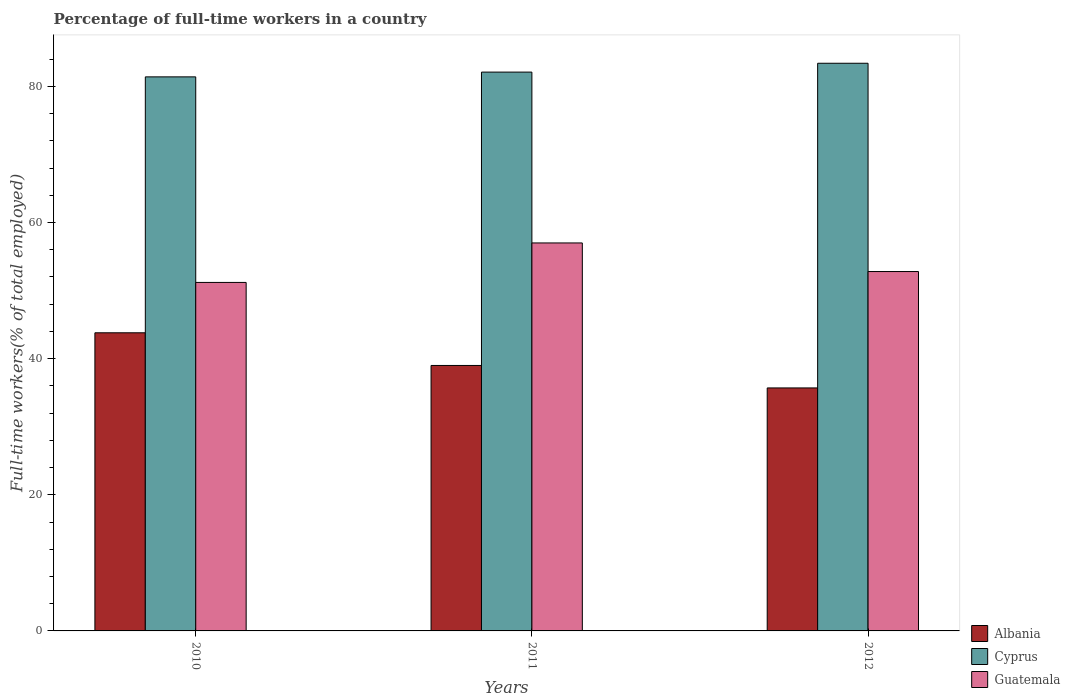How many different coloured bars are there?
Provide a short and direct response. 3. How many groups of bars are there?
Your answer should be compact. 3. Are the number of bars per tick equal to the number of legend labels?
Make the answer very short. Yes. Are the number of bars on each tick of the X-axis equal?
Give a very brief answer. Yes. How many bars are there on the 1st tick from the right?
Keep it short and to the point. 3. In how many cases, is the number of bars for a given year not equal to the number of legend labels?
Provide a succinct answer. 0. What is the percentage of full-time workers in Albania in 2010?
Your answer should be compact. 43.8. Across all years, what is the maximum percentage of full-time workers in Albania?
Provide a succinct answer. 43.8. Across all years, what is the minimum percentage of full-time workers in Guatemala?
Your answer should be compact. 51.2. In which year was the percentage of full-time workers in Albania maximum?
Provide a short and direct response. 2010. What is the total percentage of full-time workers in Albania in the graph?
Provide a short and direct response. 118.5. What is the difference between the percentage of full-time workers in Albania in 2011 and that in 2012?
Your answer should be very brief. 3.3. What is the difference between the percentage of full-time workers in Cyprus in 2010 and the percentage of full-time workers in Albania in 2012?
Keep it short and to the point. 45.7. What is the average percentage of full-time workers in Albania per year?
Provide a short and direct response. 39.5. In the year 2012, what is the difference between the percentage of full-time workers in Guatemala and percentage of full-time workers in Albania?
Provide a succinct answer. 17.1. In how many years, is the percentage of full-time workers in Guatemala greater than 40 %?
Make the answer very short. 3. What is the ratio of the percentage of full-time workers in Cyprus in 2010 to that in 2011?
Provide a short and direct response. 0.99. Is the percentage of full-time workers in Cyprus in 2010 less than that in 2012?
Your response must be concise. Yes. Is the difference between the percentage of full-time workers in Guatemala in 2010 and 2012 greater than the difference between the percentage of full-time workers in Albania in 2010 and 2012?
Offer a terse response. No. What is the difference between the highest and the second highest percentage of full-time workers in Guatemala?
Ensure brevity in your answer.  4.2. In how many years, is the percentage of full-time workers in Albania greater than the average percentage of full-time workers in Albania taken over all years?
Provide a short and direct response. 1. Is the sum of the percentage of full-time workers in Cyprus in 2010 and 2011 greater than the maximum percentage of full-time workers in Guatemala across all years?
Your answer should be very brief. Yes. What does the 2nd bar from the left in 2012 represents?
Offer a terse response. Cyprus. What does the 2nd bar from the right in 2011 represents?
Provide a short and direct response. Cyprus. How many years are there in the graph?
Provide a succinct answer. 3. Does the graph contain any zero values?
Keep it short and to the point. No. Does the graph contain grids?
Your answer should be very brief. No. How are the legend labels stacked?
Ensure brevity in your answer.  Vertical. What is the title of the graph?
Keep it short and to the point. Percentage of full-time workers in a country. Does "Belarus" appear as one of the legend labels in the graph?
Ensure brevity in your answer.  No. What is the label or title of the X-axis?
Keep it short and to the point. Years. What is the label or title of the Y-axis?
Provide a short and direct response. Full-time workers(% of total employed). What is the Full-time workers(% of total employed) of Albania in 2010?
Offer a terse response. 43.8. What is the Full-time workers(% of total employed) in Cyprus in 2010?
Provide a succinct answer. 81.4. What is the Full-time workers(% of total employed) in Guatemala in 2010?
Offer a very short reply. 51.2. What is the Full-time workers(% of total employed) of Cyprus in 2011?
Your answer should be compact. 82.1. What is the Full-time workers(% of total employed) of Guatemala in 2011?
Your answer should be very brief. 57. What is the Full-time workers(% of total employed) of Albania in 2012?
Give a very brief answer. 35.7. What is the Full-time workers(% of total employed) of Cyprus in 2012?
Ensure brevity in your answer.  83.4. What is the Full-time workers(% of total employed) in Guatemala in 2012?
Keep it short and to the point. 52.8. Across all years, what is the maximum Full-time workers(% of total employed) in Albania?
Your answer should be very brief. 43.8. Across all years, what is the maximum Full-time workers(% of total employed) in Cyprus?
Provide a short and direct response. 83.4. Across all years, what is the minimum Full-time workers(% of total employed) of Albania?
Keep it short and to the point. 35.7. Across all years, what is the minimum Full-time workers(% of total employed) in Cyprus?
Ensure brevity in your answer.  81.4. Across all years, what is the minimum Full-time workers(% of total employed) of Guatemala?
Provide a succinct answer. 51.2. What is the total Full-time workers(% of total employed) in Albania in the graph?
Offer a terse response. 118.5. What is the total Full-time workers(% of total employed) in Cyprus in the graph?
Provide a short and direct response. 246.9. What is the total Full-time workers(% of total employed) in Guatemala in the graph?
Provide a short and direct response. 161. What is the difference between the Full-time workers(% of total employed) in Guatemala in 2010 and that in 2011?
Offer a terse response. -5.8. What is the difference between the Full-time workers(% of total employed) of Cyprus in 2010 and that in 2012?
Your answer should be very brief. -2. What is the difference between the Full-time workers(% of total employed) in Albania in 2011 and that in 2012?
Ensure brevity in your answer.  3.3. What is the difference between the Full-time workers(% of total employed) in Cyprus in 2011 and that in 2012?
Provide a succinct answer. -1.3. What is the difference between the Full-time workers(% of total employed) in Guatemala in 2011 and that in 2012?
Keep it short and to the point. 4.2. What is the difference between the Full-time workers(% of total employed) in Albania in 2010 and the Full-time workers(% of total employed) in Cyprus in 2011?
Provide a short and direct response. -38.3. What is the difference between the Full-time workers(% of total employed) of Cyprus in 2010 and the Full-time workers(% of total employed) of Guatemala in 2011?
Keep it short and to the point. 24.4. What is the difference between the Full-time workers(% of total employed) in Albania in 2010 and the Full-time workers(% of total employed) in Cyprus in 2012?
Your answer should be compact. -39.6. What is the difference between the Full-time workers(% of total employed) in Cyprus in 2010 and the Full-time workers(% of total employed) in Guatemala in 2012?
Your answer should be very brief. 28.6. What is the difference between the Full-time workers(% of total employed) of Albania in 2011 and the Full-time workers(% of total employed) of Cyprus in 2012?
Your answer should be very brief. -44.4. What is the difference between the Full-time workers(% of total employed) of Cyprus in 2011 and the Full-time workers(% of total employed) of Guatemala in 2012?
Provide a succinct answer. 29.3. What is the average Full-time workers(% of total employed) of Albania per year?
Your answer should be very brief. 39.5. What is the average Full-time workers(% of total employed) in Cyprus per year?
Make the answer very short. 82.3. What is the average Full-time workers(% of total employed) in Guatemala per year?
Make the answer very short. 53.67. In the year 2010, what is the difference between the Full-time workers(% of total employed) in Albania and Full-time workers(% of total employed) in Cyprus?
Your answer should be compact. -37.6. In the year 2010, what is the difference between the Full-time workers(% of total employed) in Albania and Full-time workers(% of total employed) in Guatemala?
Provide a succinct answer. -7.4. In the year 2010, what is the difference between the Full-time workers(% of total employed) in Cyprus and Full-time workers(% of total employed) in Guatemala?
Give a very brief answer. 30.2. In the year 2011, what is the difference between the Full-time workers(% of total employed) of Albania and Full-time workers(% of total employed) of Cyprus?
Your answer should be very brief. -43.1. In the year 2011, what is the difference between the Full-time workers(% of total employed) of Albania and Full-time workers(% of total employed) of Guatemala?
Your answer should be very brief. -18. In the year 2011, what is the difference between the Full-time workers(% of total employed) in Cyprus and Full-time workers(% of total employed) in Guatemala?
Give a very brief answer. 25.1. In the year 2012, what is the difference between the Full-time workers(% of total employed) of Albania and Full-time workers(% of total employed) of Cyprus?
Offer a very short reply. -47.7. In the year 2012, what is the difference between the Full-time workers(% of total employed) in Albania and Full-time workers(% of total employed) in Guatemala?
Your answer should be compact. -17.1. In the year 2012, what is the difference between the Full-time workers(% of total employed) of Cyprus and Full-time workers(% of total employed) of Guatemala?
Give a very brief answer. 30.6. What is the ratio of the Full-time workers(% of total employed) in Albania in 2010 to that in 2011?
Your answer should be very brief. 1.12. What is the ratio of the Full-time workers(% of total employed) of Guatemala in 2010 to that in 2011?
Give a very brief answer. 0.9. What is the ratio of the Full-time workers(% of total employed) of Albania in 2010 to that in 2012?
Your response must be concise. 1.23. What is the ratio of the Full-time workers(% of total employed) of Cyprus in 2010 to that in 2012?
Offer a very short reply. 0.98. What is the ratio of the Full-time workers(% of total employed) in Guatemala in 2010 to that in 2012?
Your answer should be very brief. 0.97. What is the ratio of the Full-time workers(% of total employed) of Albania in 2011 to that in 2012?
Ensure brevity in your answer.  1.09. What is the ratio of the Full-time workers(% of total employed) of Cyprus in 2011 to that in 2012?
Your response must be concise. 0.98. What is the ratio of the Full-time workers(% of total employed) in Guatemala in 2011 to that in 2012?
Ensure brevity in your answer.  1.08. What is the difference between the highest and the second highest Full-time workers(% of total employed) in Albania?
Your response must be concise. 4.8. What is the difference between the highest and the lowest Full-time workers(% of total employed) in Albania?
Your response must be concise. 8.1. What is the difference between the highest and the lowest Full-time workers(% of total employed) in Guatemala?
Make the answer very short. 5.8. 